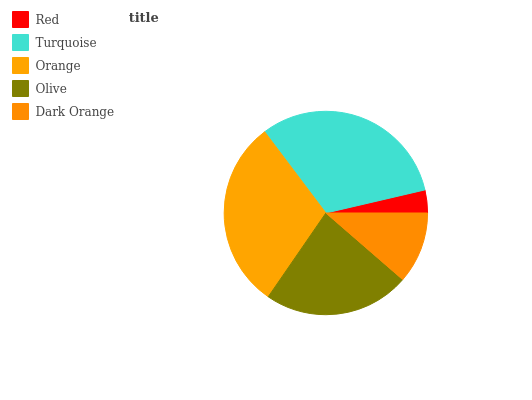Is Red the minimum?
Answer yes or no. Yes. Is Turquoise the maximum?
Answer yes or no. Yes. Is Orange the minimum?
Answer yes or no. No. Is Orange the maximum?
Answer yes or no. No. Is Turquoise greater than Orange?
Answer yes or no. Yes. Is Orange less than Turquoise?
Answer yes or no. Yes. Is Orange greater than Turquoise?
Answer yes or no. No. Is Turquoise less than Orange?
Answer yes or no. No. Is Olive the high median?
Answer yes or no. Yes. Is Olive the low median?
Answer yes or no. Yes. Is Dark Orange the high median?
Answer yes or no. No. Is Orange the low median?
Answer yes or no. No. 